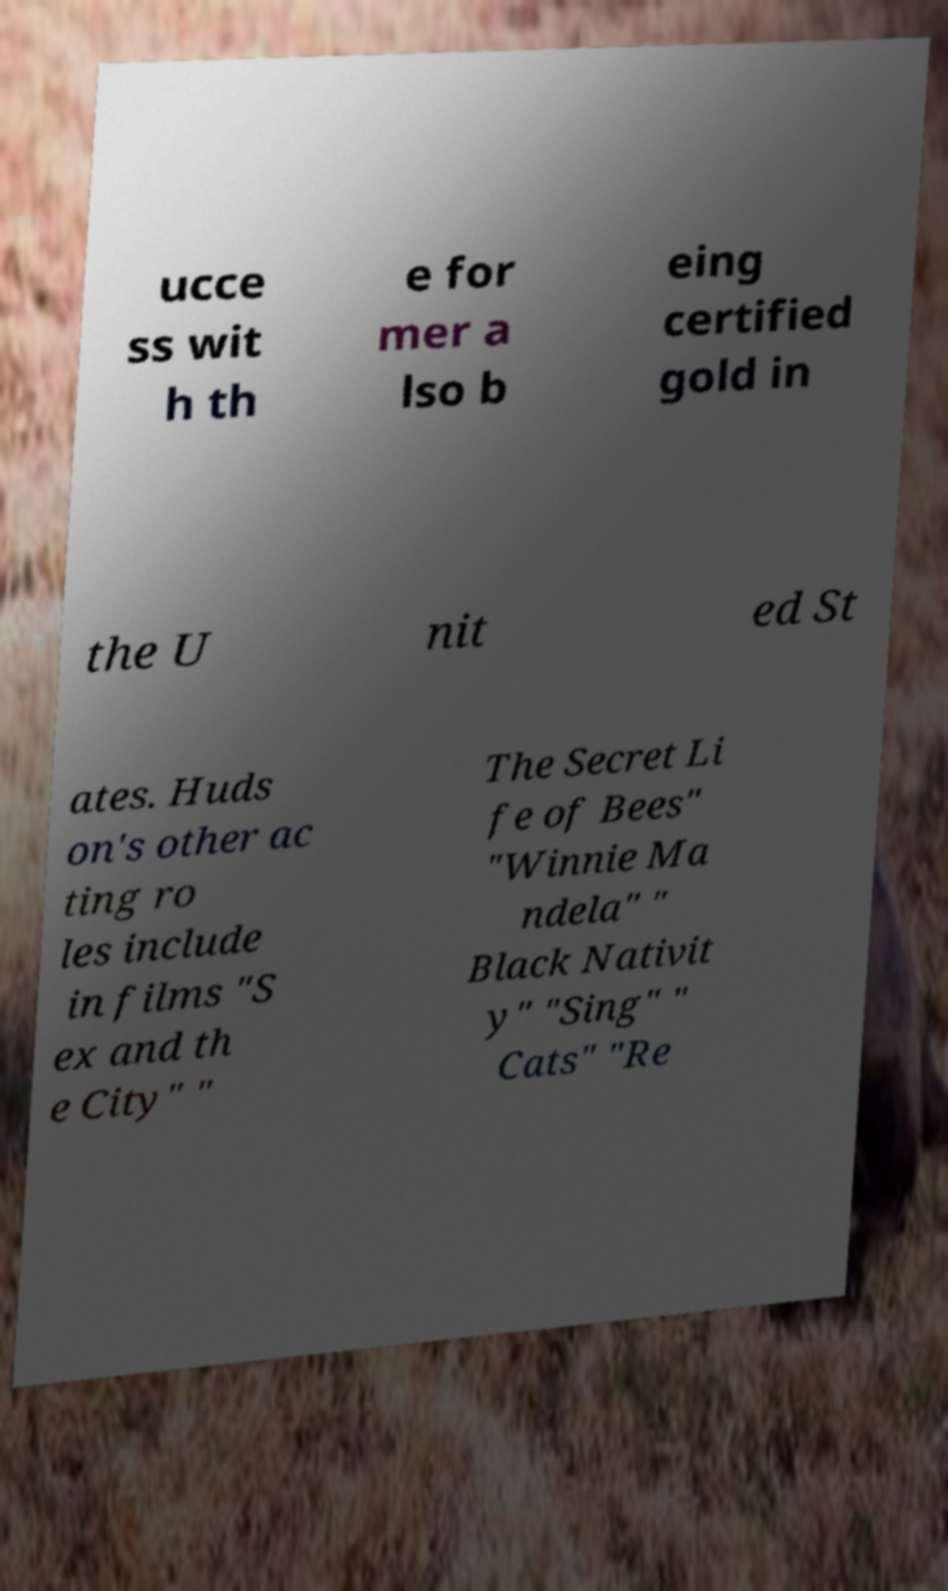What messages or text are displayed in this image? I need them in a readable, typed format. ucce ss wit h th e for mer a lso b eing certified gold in the U nit ed St ates. Huds on's other ac ting ro les include in films "S ex and th e City" " The Secret Li fe of Bees" "Winnie Ma ndela" " Black Nativit y" "Sing" " Cats" "Re 